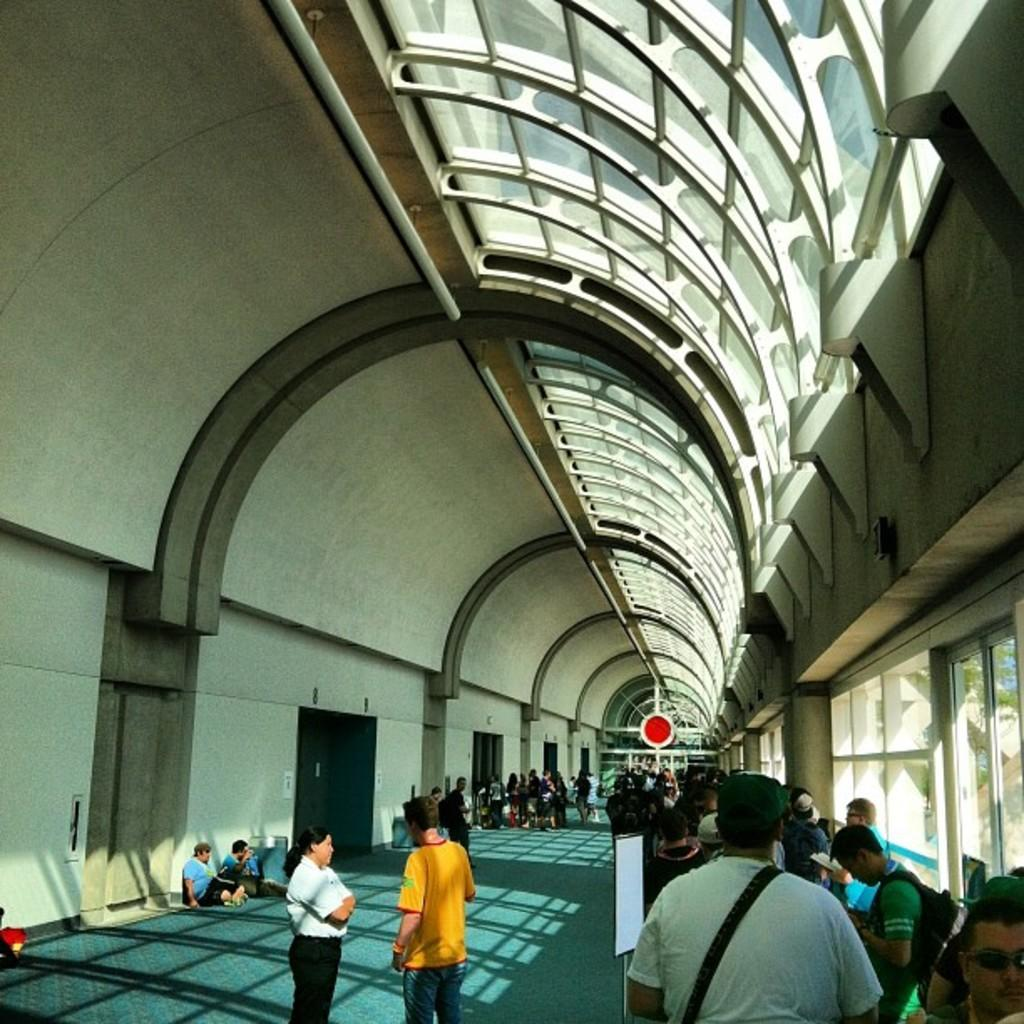How many persons are standing on the right side of the image? There are persons standing on the right side of the image. How many persons are standing on the left side of the image? There are two persons standing on the left side of the image. Can you describe the persons in the background of the image? There are other persons in the background of the image. What is visible above the persons in the image? There is a roof visible above the persons. What type of fruit is being used to oil the steps in the image? There is no fruit or steps present in the image, so it is not possible to answer that question. 